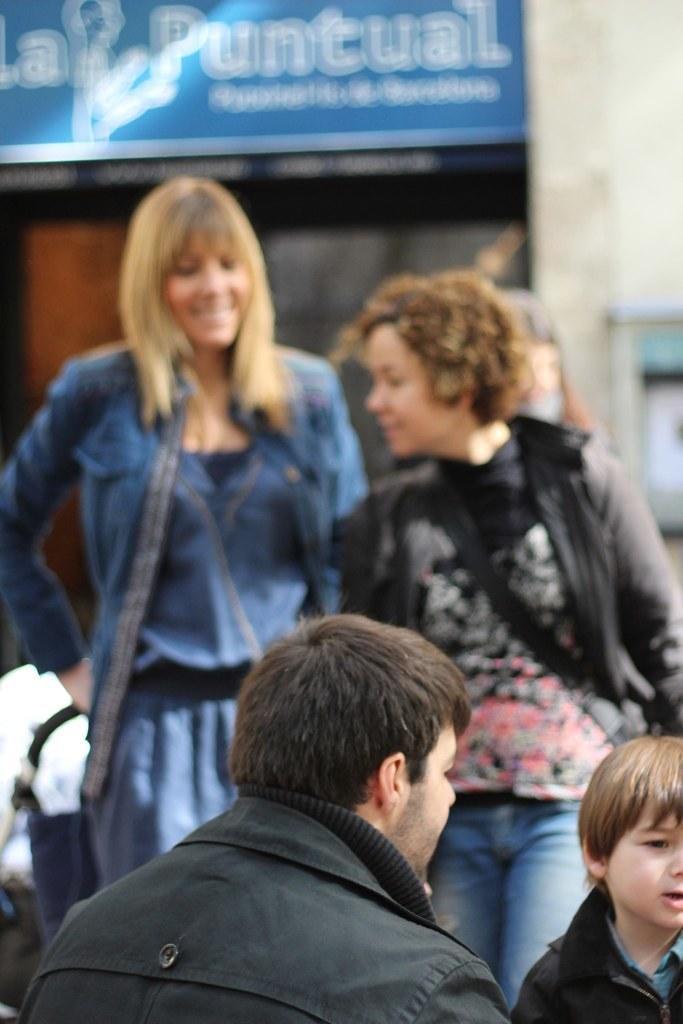In one or two sentences, can you explain what this image depicts? In the foreground of this picture, there is a man in black jacket at the bottom and a boy on the right bottom corner. In the background, there are two woman, wall and a blue board. 